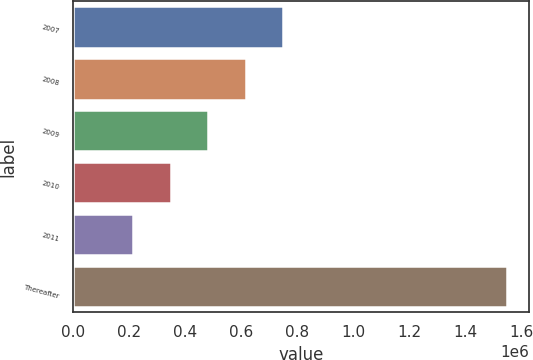<chart> <loc_0><loc_0><loc_500><loc_500><bar_chart><fcel>2007<fcel>2008<fcel>2009<fcel>2010<fcel>2011<fcel>Thereafter<nl><fcel>748217<fcel>614847<fcel>481477<fcel>348106<fcel>214736<fcel>1.54844e+06<nl></chart> 